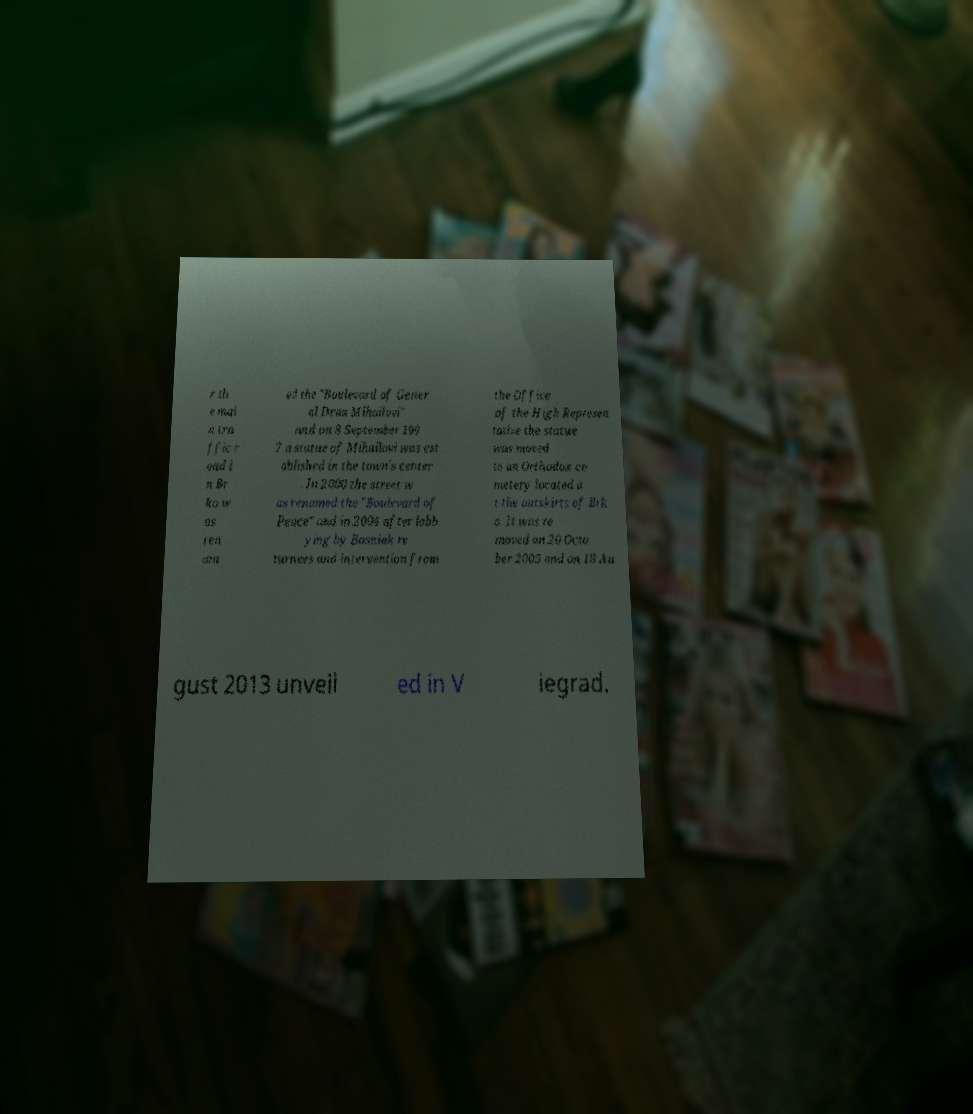What messages or text are displayed in this image? I need them in a readable, typed format. r th e mai n tra ffic r oad i n Br ko w as ren am ed the "Boulevard of Gener al Draa Mihailovi" and on 8 September 199 7 a statue of Mihailovi was est ablished in the town's center . In 2000 the street w as renamed the "Boulevard of Peace" and in 2004 after lobb ying by Bosniak re turnees and intervention from the Office of the High Represen tative the statue was moved to an Orthodox ce metery located a t the outskirts of Brk o. It was re moved on 20 Octo ber 2005 and on 18 Au gust 2013 unveil ed in V iegrad. 